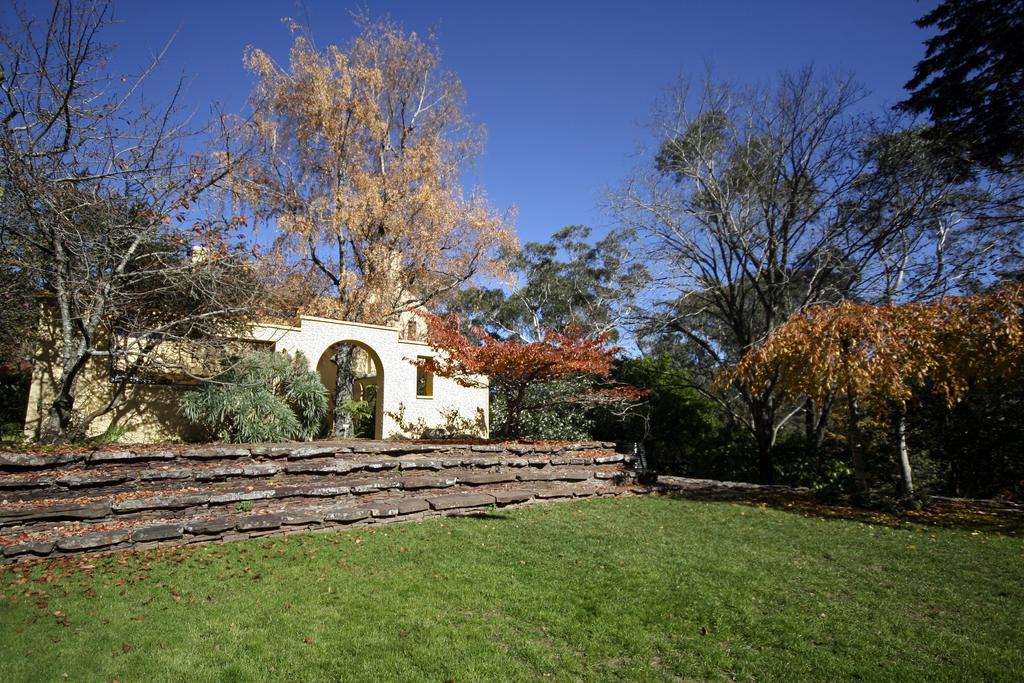How would you summarize this image in a sentence or two? In this image I can see grass, fence, trees, building and the sky. This image is taken may be during a day. 